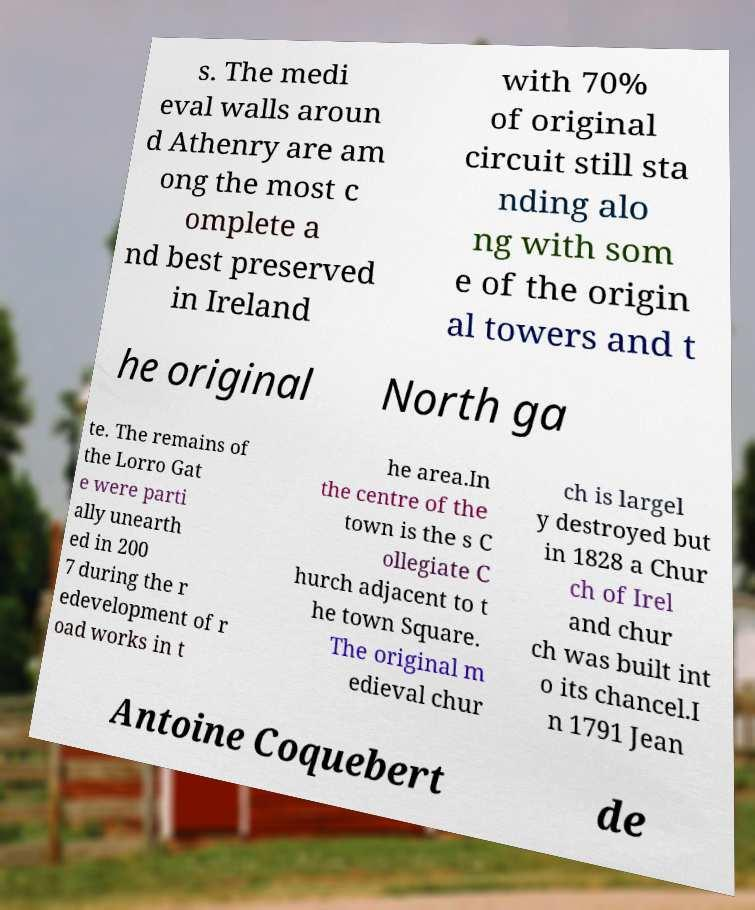Could you assist in decoding the text presented in this image and type it out clearly? s. The medi eval walls aroun d Athenry are am ong the most c omplete a nd best preserved in Ireland with 70% of original circuit still sta nding alo ng with som e of the origin al towers and t he original North ga te. The remains of the Lorro Gat e were parti ally unearth ed in 200 7 during the r edevelopment of r oad works in t he area.In the centre of the town is the s C ollegiate C hurch adjacent to t he town Square. The original m edieval chur ch is largel y destroyed but in 1828 a Chur ch of Irel and chur ch was built int o its chancel.I n 1791 Jean Antoine Coquebert de 